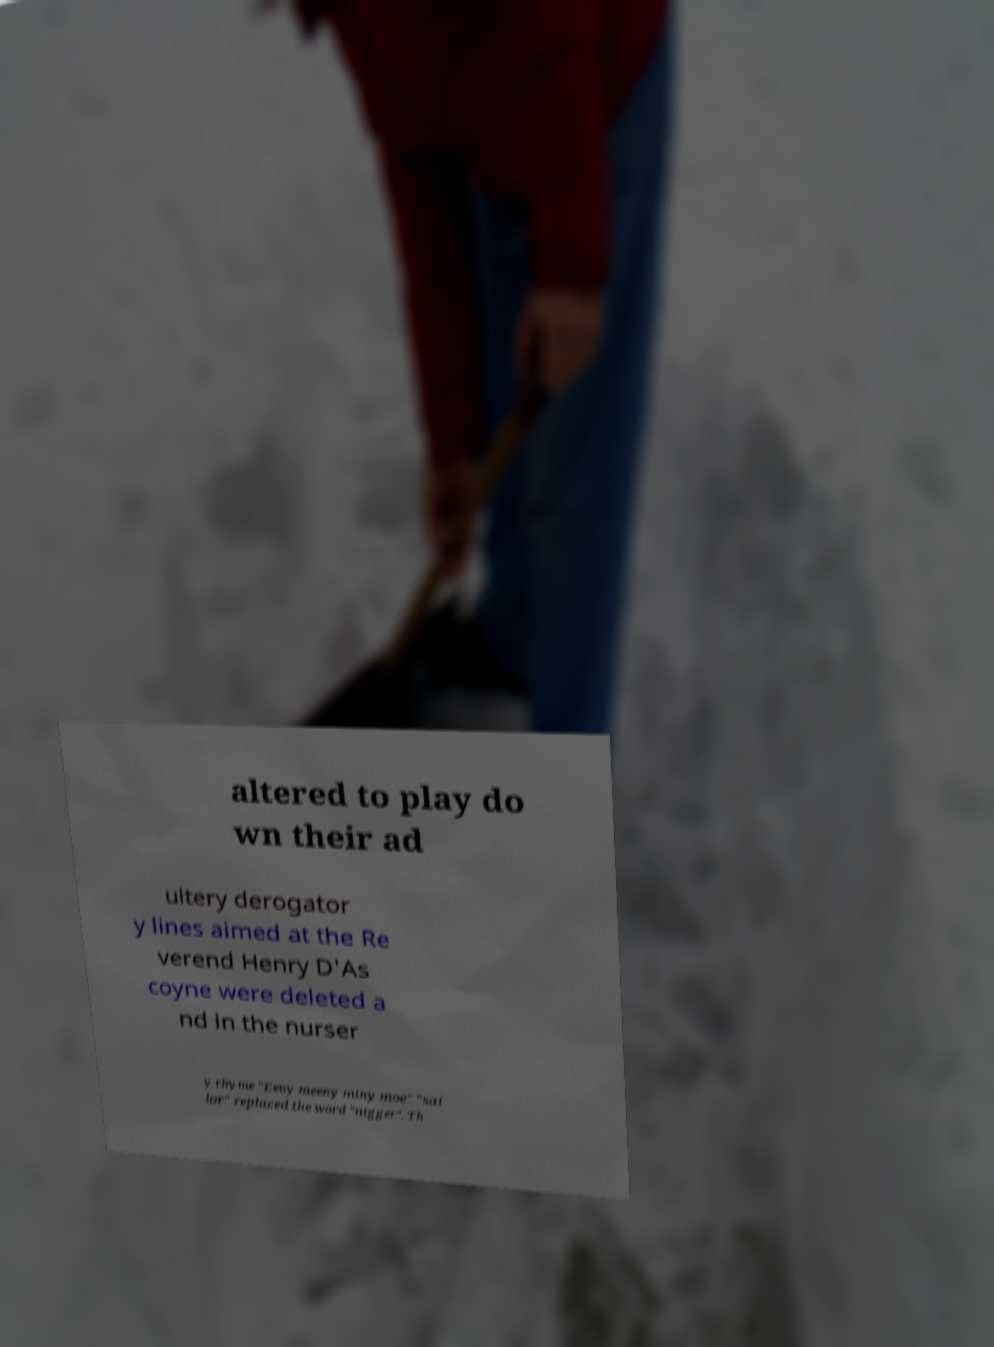What messages or text are displayed in this image? I need them in a readable, typed format. altered to play do wn their ad ultery derogator y lines aimed at the Re verend Henry D'As coyne were deleted a nd in the nurser y rhyme "Eeny meeny miny moe" "sai lor" replaced the word "nigger". Th 